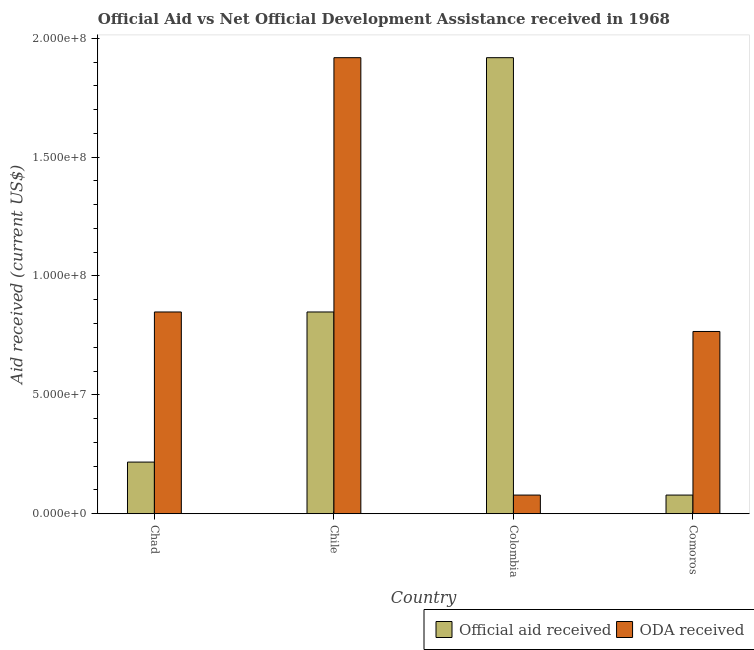How many groups of bars are there?
Your answer should be very brief. 4. Are the number of bars per tick equal to the number of legend labels?
Provide a short and direct response. Yes. What is the label of the 1st group of bars from the left?
Your answer should be very brief. Chad. In how many cases, is the number of bars for a given country not equal to the number of legend labels?
Offer a terse response. 0. What is the oda received in Colombia?
Make the answer very short. 7.85e+06. Across all countries, what is the maximum oda received?
Keep it short and to the point. 1.92e+08. Across all countries, what is the minimum official aid received?
Offer a very short reply. 7.85e+06. In which country was the official aid received maximum?
Provide a short and direct response. Colombia. What is the total oda received in the graph?
Offer a terse response. 3.61e+08. What is the difference between the oda received in Chad and that in Comoros?
Provide a succinct answer. 8.20e+06. What is the difference between the oda received in Comoros and the official aid received in Chad?
Ensure brevity in your answer.  5.49e+07. What is the average official aid received per country?
Provide a succinct answer. 7.66e+07. What is the difference between the oda received and official aid received in Comoros?
Provide a succinct answer. 6.88e+07. What is the ratio of the official aid received in Chad to that in Chile?
Offer a terse response. 0.26. What is the difference between the highest and the second highest oda received?
Offer a very short reply. 1.07e+08. What is the difference between the highest and the lowest official aid received?
Give a very brief answer. 1.84e+08. What does the 2nd bar from the left in Colombia represents?
Provide a succinct answer. ODA received. What does the 1st bar from the right in Chad represents?
Provide a succinct answer. ODA received. How many bars are there?
Provide a short and direct response. 8. How many countries are there in the graph?
Give a very brief answer. 4. Are the values on the major ticks of Y-axis written in scientific E-notation?
Your response must be concise. Yes. Does the graph contain any zero values?
Offer a very short reply. No. Where does the legend appear in the graph?
Your response must be concise. Bottom right. How are the legend labels stacked?
Your answer should be compact. Horizontal. What is the title of the graph?
Give a very brief answer. Official Aid vs Net Official Development Assistance received in 1968 . What is the label or title of the X-axis?
Your answer should be compact. Country. What is the label or title of the Y-axis?
Keep it short and to the point. Aid received (current US$). What is the Aid received (current US$) in Official aid received in Chad?
Offer a very short reply. 2.17e+07. What is the Aid received (current US$) of ODA received in Chad?
Offer a terse response. 8.49e+07. What is the Aid received (current US$) of Official aid received in Chile?
Your answer should be compact. 8.49e+07. What is the Aid received (current US$) of ODA received in Chile?
Give a very brief answer. 1.92e+08. What is the Aid received (current US$) in Official aid received in Colombia?
Offer a terse response. 1.92e+08. What is the Aid received (current US$) of ODA received in Colombia?
Your response must be concise. 7.85e+06. What is the Aid received (current US$) in Official aid received in Comoros?
Offer a very short reply. 7.85e+06. What is the Aid received (current US$) of ODA received in Comoros?
Provide a short and direct response. 7.67e+07. Across all countries, what is the maximum Aid received (current US$) of Official aid received?
Ensure brevity in your answer.  1.92e+08. Across all countries, what is the maximum Aid received (current US$) in ODA received?
Your answer should be compact. 1.92e+08. Across all countries, what is the minimum Aid received (current US$) of Official aid received?
Your answer should be very brief. 7.85e+06. Across all countries, what is the minimum Aid received (current US$) in ODA received?
Ensure brevity in your answer.  7.85e+06. What is the total Aid received (current US$) of Official aid received in the graph?
Offer a very short reply. 3.06e+08. What is the total Aid received (current US$) in ODA received in the graph?
Make the answer very short. 3.61e+08. What is the difference between the Aid received (current US$) of Official aid received in Chad and that in Chile?
Your answer should be compact. -6.31e+07. What is the difference between the Aid received (current US$) of ODA received in Chad and that in Chile?
Your answer should be very brief. -1.07e+08. What is the difference between the Aid received (current US$) of Official aid received in Chad and that in Colombia?
Your response must be concise. -1.70e+08. What is the difference between the Aid received (current US$) of ODA received in Chad and that in Colombia?
Give a very brief answer. 7.70e+07. What is the difference between the Aid received (current US$) of Official aid received in Chad and that in Comoros?
Provide a succinct answer. 1.39e+07. What is the difference between the Aid received (current US$) in ODA received in Chad and that in Comoros?
Your answer should be compact. 8.20e+06. What is the difference between the Aid received (current US$) of Official aid received in Chile and that in Colombia?
Keep it short and to the point. -1.07e+08. What is the difference between the Aid received (current US$) of ODA received in Chile and that in Colombia?
Offer a terse response. 1.84e+08. What is the difference between the Aid received (current US$) in Official aid received in Chile and that in Comoros?
Provide a short and direct response. 7.70e+07. What is the difference between the Aid received (current US$) of ODA received in Chile and that in Comoros?
Give a very brief answer. 1.15e+08. What is the difference between the Aid received (current US$) of Official aid received in Colombia and that in Comoros?
Offer a very short reply. 1.84e+08. What is the difference between the Aid received (current US$) in ODA received in Colombia and that in Comoros?
Offer a terse response. -6.88e+07. What is the difference between the Aid received (current US$) in Official aid received in Chad and the Aid received (current US$) in ODA received in Chile?
Offer a terse response. -1.70e+08. What is the difference between the Aid received (current US$) of Official aid received in Chad and the Aid received (current US$) of ODA received in Colombia?
Your response must be concise. 1.39e+07. What is the difference between the Aid received (current US$) of Official aid received in Chad and the Aid received (current US$) of ODA received in Comoros?
Make the answer very short. -5.49e+07. What is the difference between the Aid received (current US$) of Official aid received in Chile and the Aid received (current US$) of ODA received in Colombia?
Keep it short and to the point. 7.70e+07. What is the difference between the Aid received (current US$) in Official aid received in Chile and the Aid received (current US$) in ODA received in Comoros?
Make the answer very short. 8.20e+06. What is the difference between the Aid received (current US$) of Official aid received in Colombia and the Aid received (current US$) of ODA received in Comoros?
Provide a short and direct response. 1.15e+08. What is the average Aid received (current US$) of Official aid received per country?
Give a very brief answer. 7.66e+07. What is the average Aid received (current US$) of ODA received per country?
Offer a terse response. 9.03e+07. What is the difference between the Aid received (current US$) of Official aid received and Aid received (current US$) of ODA received in Chad?
Keep it short and to the point. -6.31e+07. What is the difference between the Aid received (current US$) of Official aid received and Aid received (current US$) of ODA received in Chile?
Provide a short and direct response. -1.07e+08. What is the difference between the Aid received (current US$) in Official aid received and Aid received (current US$) in ODA received in Colombia?
Provide a succinct answer. 1.84e+08. What is the difference between the Aid received (current US$) of Official aid received and Aid received (current US$) of ODA received in Comoros?
Offer a terse response. -6.88e+07. What is the ratio of the Aid received (current US$) in Official aid received in Chad to that in Chile?
Give a very brief answer. 0.26. What is the ratio of the Aid received (current US$) in ODA received in Chad to that in Chile?
Keep it short and to the point. 0.44. What is the ratio of the Aid received (current US$) of Official aid received in Chad to that in Colombia?
Give a very brief answer. 0.11. What is the ratio of the Aid received (current US$) in ODA received in Chad to that in Colombia?
Your answer should be very brief. 10.81. What is the ratio of the Aid received (current US$) of Official aid received in Chad to that in Comoros?
Ensure brevity in your answer.  2.77. What is the ratio of the Aid received (current US$) in ODA received in Chad to that in Comoros?
Provide a short and direct response. 1.11. What is the ratio of the Aid received (current US$) of Official aid received in Chile to that in Colombia?
Give a very brief answer. 0.44. What is the ratio of the Aid received (current US$) of ODA received in Chile to that in Colombia?
Give a very brief answer. 24.44. What is the ratio of the Aid received (current US$) of Official aid received in Chile to that in Comoros?
Your answer should be compact. 10.81. What is the ratio of the Aid received (current US$) in ODA received in Chile to that in Comoros?
Provide a short and direct response. 2.5. What is the ratio of the Aid received (current US$) in Official aid received in Colombia to that in Comoros?
Provide a short and direct response. 24.44. What is the ratio of the Aid received (current US$) in ODA received in Colombia to that in Comoros?
Provide a succinct answer. 0.1. What is the difference between the highest and the second highest Aid received (current US$) in Official aid received?
Your answer should be compact. 1.07e+08. What is the difference between the highest and the second highest Aid received (current US$) of ODA received?
Keep it short and to the point. 1.07e+08. What is the difference between the highest and the lowest Aid received (current US$) in Official aid received?
Provide a short and direct response. 1.84e+08. What is the difference between the highest and the lowest Aid received (current US$) of ODA received?
Give a very brief answer. 1.84e+08. 